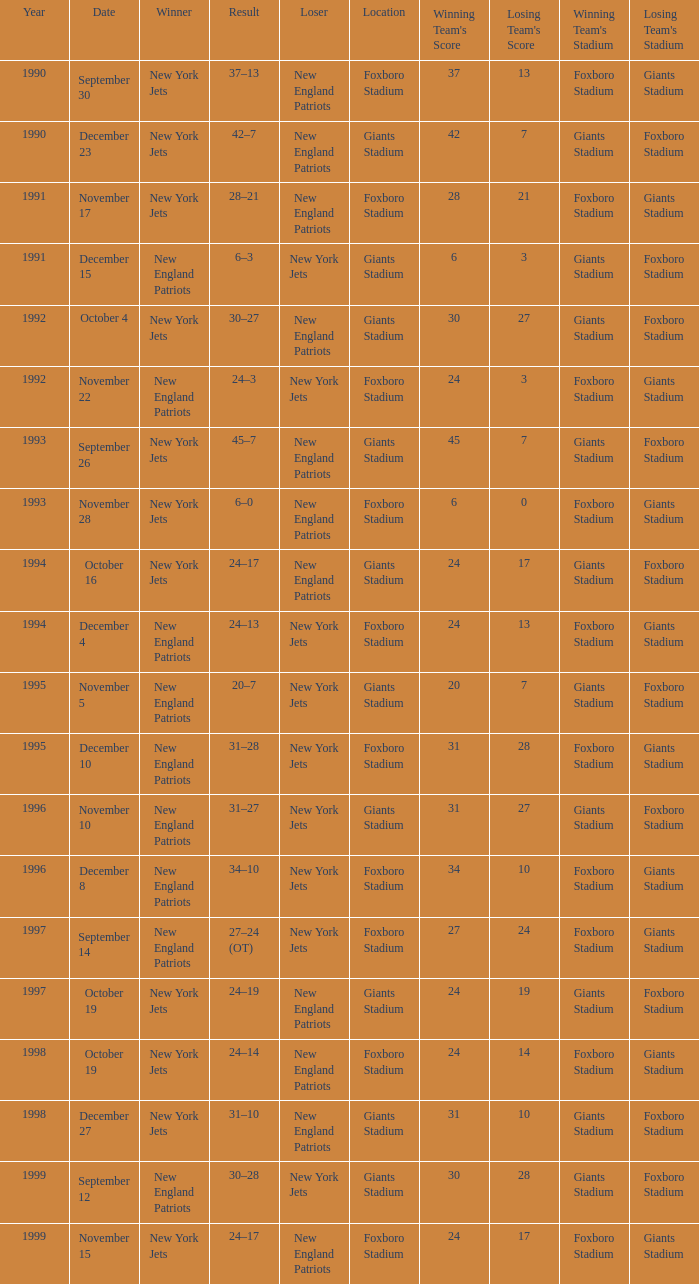What is the location when the new york jets lost earlier than 1997 and a Result of 31–28? Foxboro Stadium. 